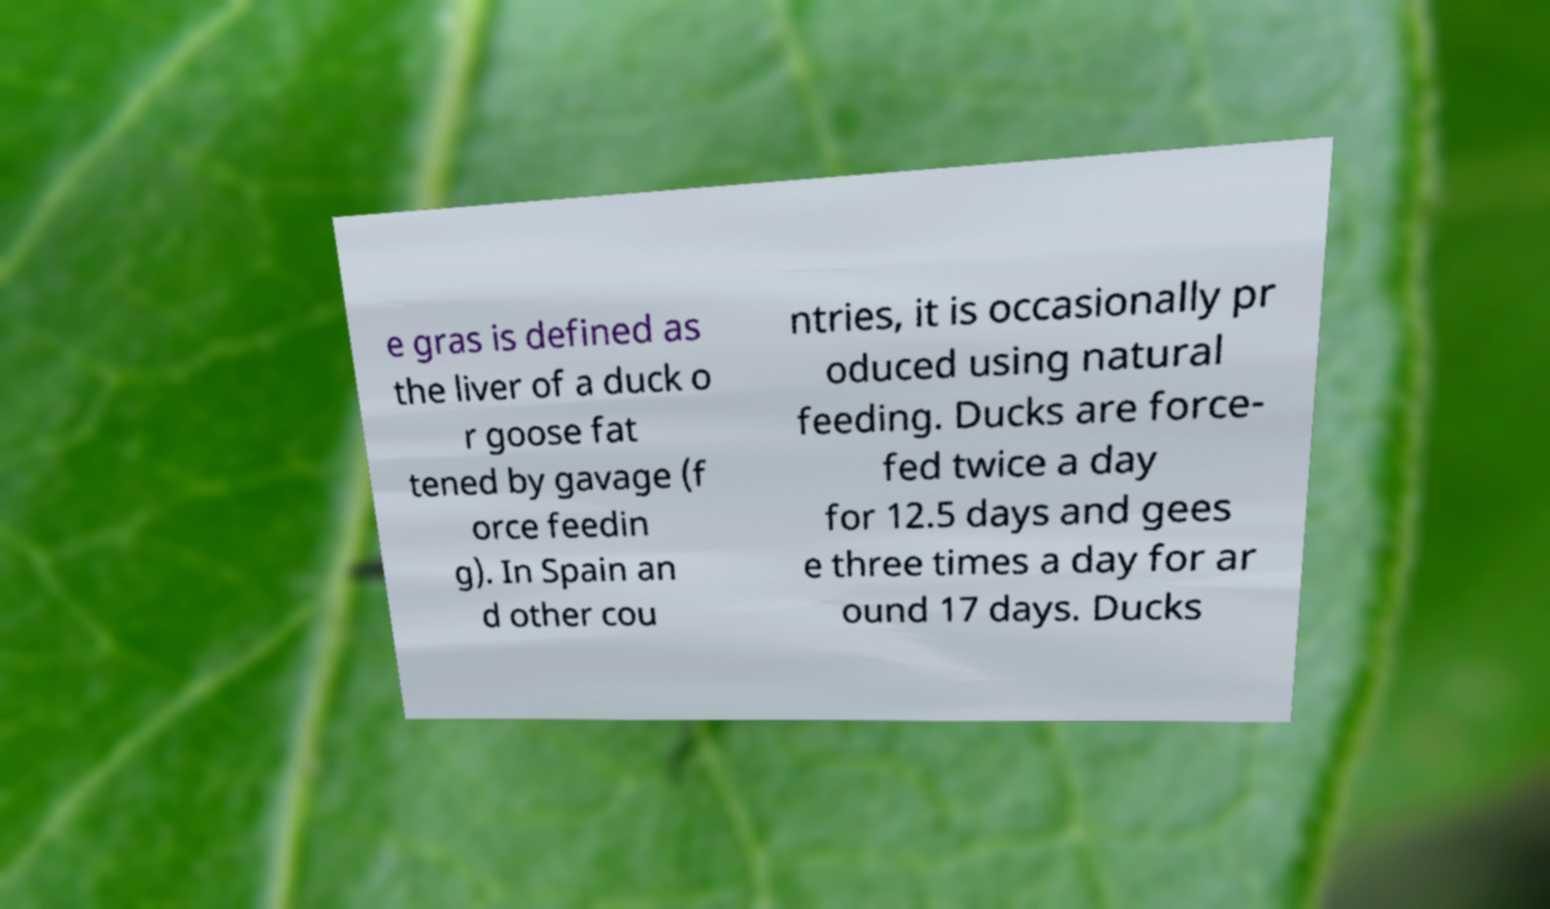There's text embedded in this image that I need extracted. Can you transcribe it verbatim? e gras is defined as the liver of a duck o r goose fat tened by gavage (f orce feedin g). In Spain an d other cou ntries, it is occasionally pr oduced using natural feeding. Ducks are force- fed twice a day for 12.5 days and gees e three times a day for ar ound 17 days. Ducks 